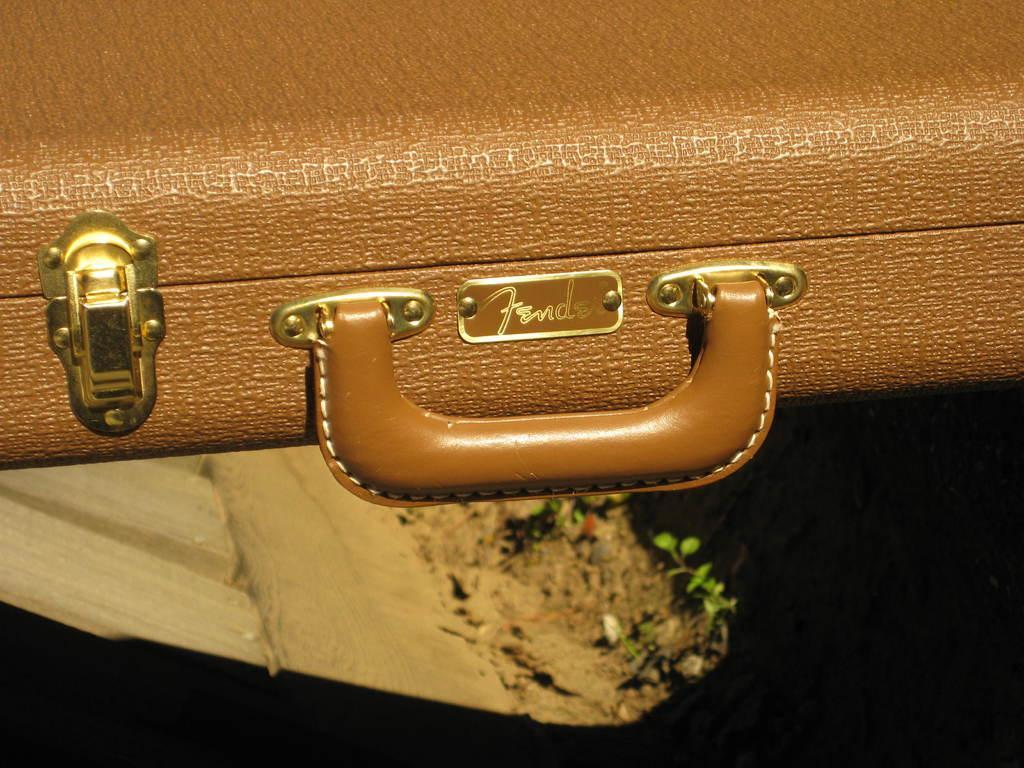Could you give a brief overview of what you see in this image? I can see in this image a suitcase of a brown color with a handle on it. 